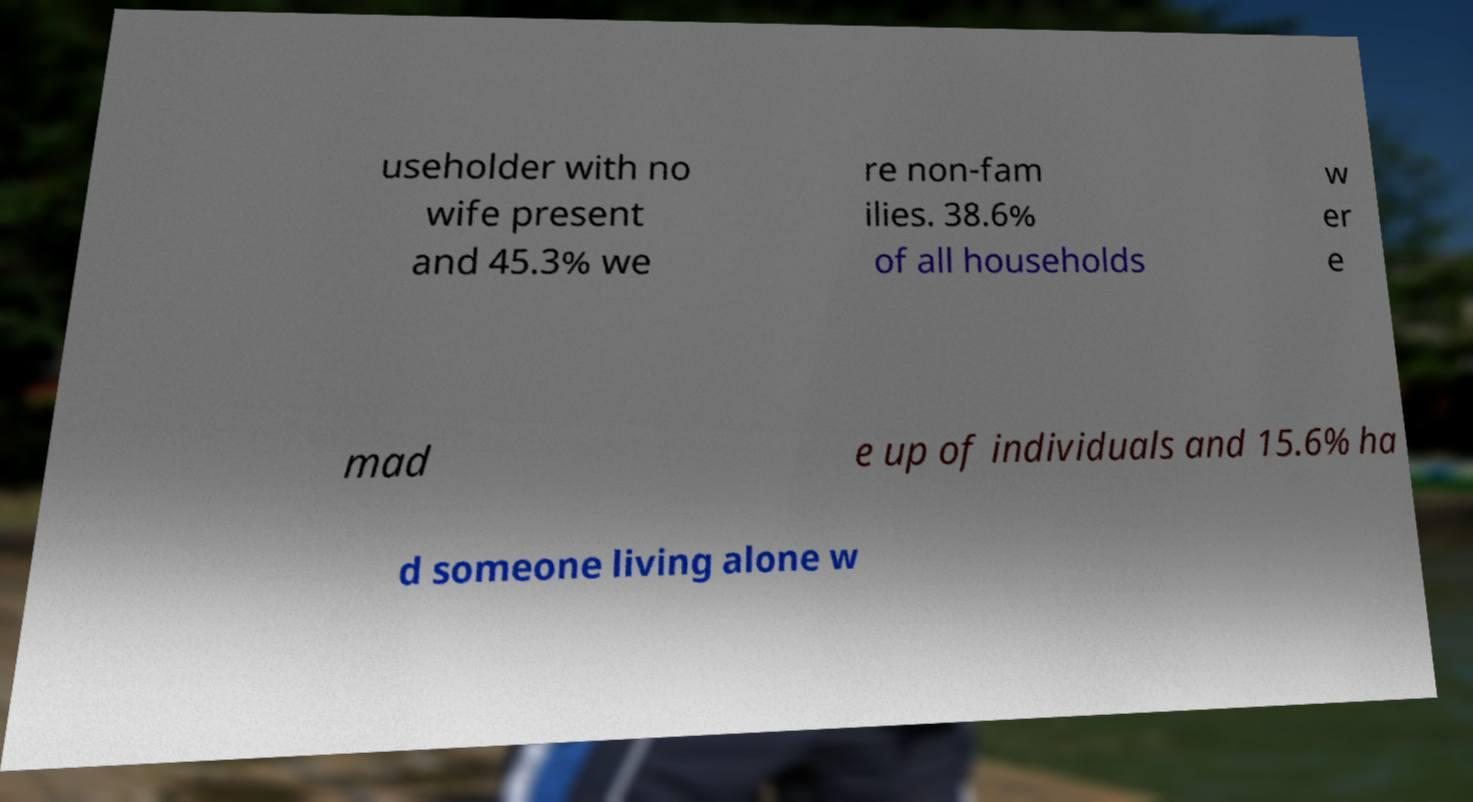Could you extract and type out the text from this image? useholder with no wife present and 45.3% we re non-fam ilies. 38.6% of all households w er e mad e up of individuals and 15.6% ha d someone living alone w 